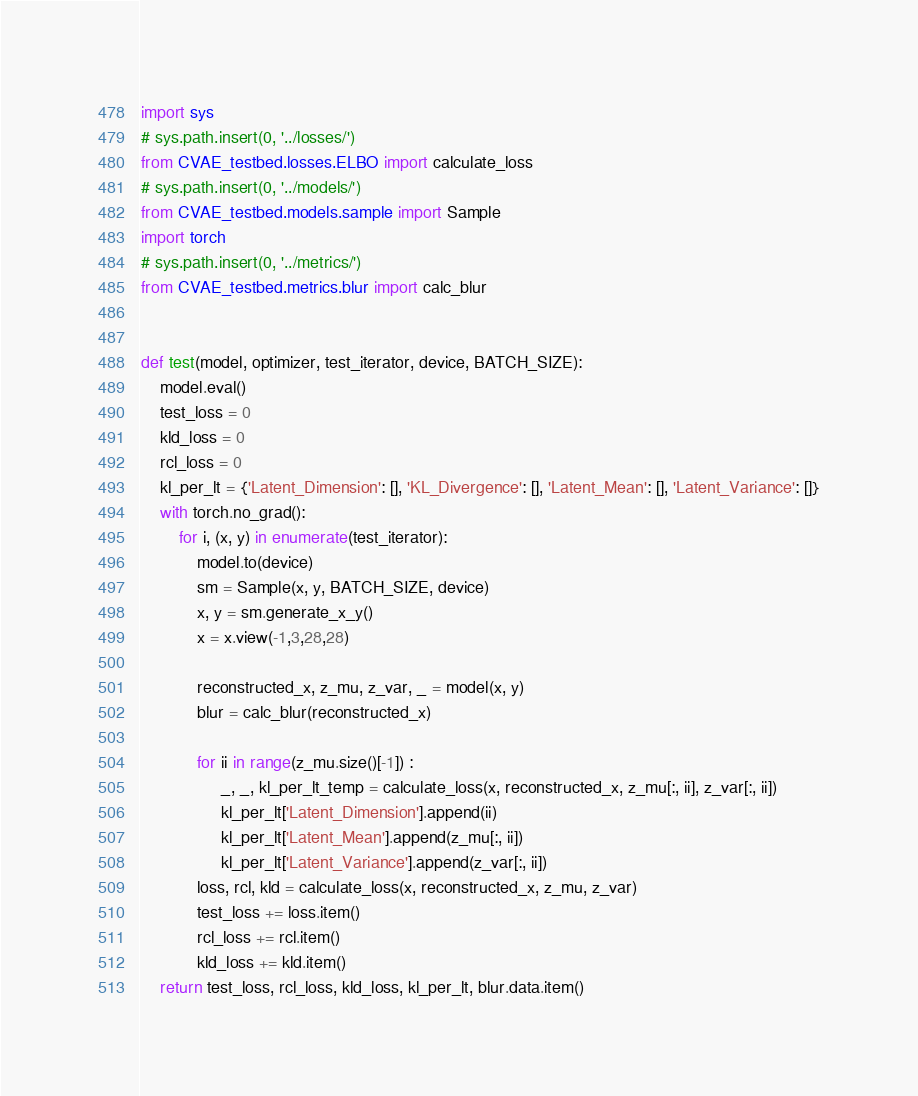<code> <loc_0><loc_0><loc_500><loc_500><_Python_>import sys
# sys.path.insert(0, '../losses/')
from CVAE_testbed.losses.ELBO import calculate_loss
# sys.path.insert(0, '../models/')
from CVAE_testbed.models.sample import Sample
import torch
# sys.path.insert(0, '../metrics/')
from CVAE_testbed.metrics.blur import calc_blur


def test(model, optimizer, test_iterator, device, BATCH_SIZE):
    model.eval()
    test_loss = 0
    kld_loss = 0
    rcl_loss = 0
    kl_per_lt = {'Latent_Dimension': [], 'KL_Divergence': [], 'Latent_Mean': [], 'Latent_Variance': []}
    with torch.no_grad():
        for i, (x, y) in enumerate(test_iterator):
            model.to(device)
            sm = Sample(x, y, BATCH_SIZE, device)
            x, y = sm.generate_x_y()
            x = x.view(-1,3,28,28)

            reconstructed_x, z_mu, z_var, _ = model(x, y)
            blur = calc_blur(reconstructed_x)

            for ii in range(z_mu.size()[-1]) :
                 _, _, kl_per_lt_temp = calculate_loss(x, reconstructed_x, z_mu[:, ii], z_var[:, ii])
                 kl_per_lt['Latent_Dimension'].append(ii)
                 kl_per_lt['Latent_Mean'].append(z_mu[:, ii])
                 kl_per_lt['Latent_Variance'].append(z_var[:, ii])
            loss, rcl, kld = calculate_loss(x, reconstructed_x, z_mu, z_var)
            test_loss += loss.item()
            rcl_loss += rcl.item()
            kld_loss += kld.item()
    return test_loss, rcl_loss, kld_loss, kl_per_lt, blur.data.item()
</code> 